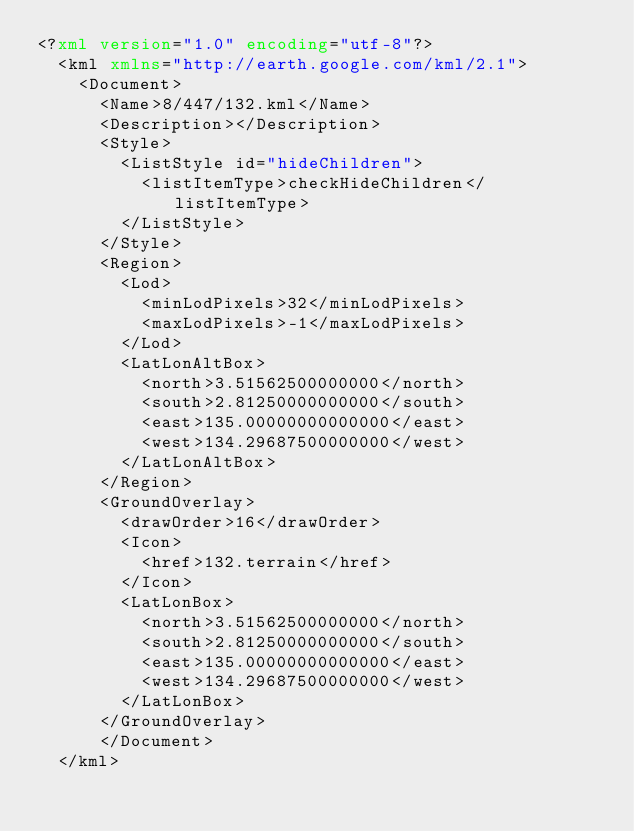Convert code to text. <code><loc_0><loc_0><loc_500><loc_500><_XML_><?xml version="1.0" encoding="utf-8"?>
	<kml xmlns="http://earth.google.com/kml/2.1">
	  <Document>
	    <Name>8/447/132.kml</Name>
	    <Description></Description>
	    <Style>
	      <ListStyle id="hideChildren">
	        <listItemType>checkHideChildren</listItemType>
	      </ListStyle>
	    </Style>
	    <Region>
	      <Lod>
	        <minLodPixels>32</minLodPixels>
	        <maxLodPixels>-1</maxLodPixels>
	      </Lod>
	      <LatLonAltBox>
	        <north>3.51562500000000</north>
	        <south>2.81250000000000</south>
	        <east>135.00000000000000</east>
	        <west>134.29687500000000</west>
	      </LatLonAltBox>
	    </Region>
	    <GroundOverlay>
	      <drawOrder>16</drawOrder>
	      <Icon>
	        <href>132.terrain</href>
	      </Icon>
	      <LatLonBox>
	        <north>3.51562500000000</north>
	        <south>2.81250000000000</south>
	        <east>135.00000000000000</east>
	        <west>134.29687500000000</west>
	      </LatLonBox>
	    </GroundOverlay>
		  </Document>
	</kml>
	</code> 